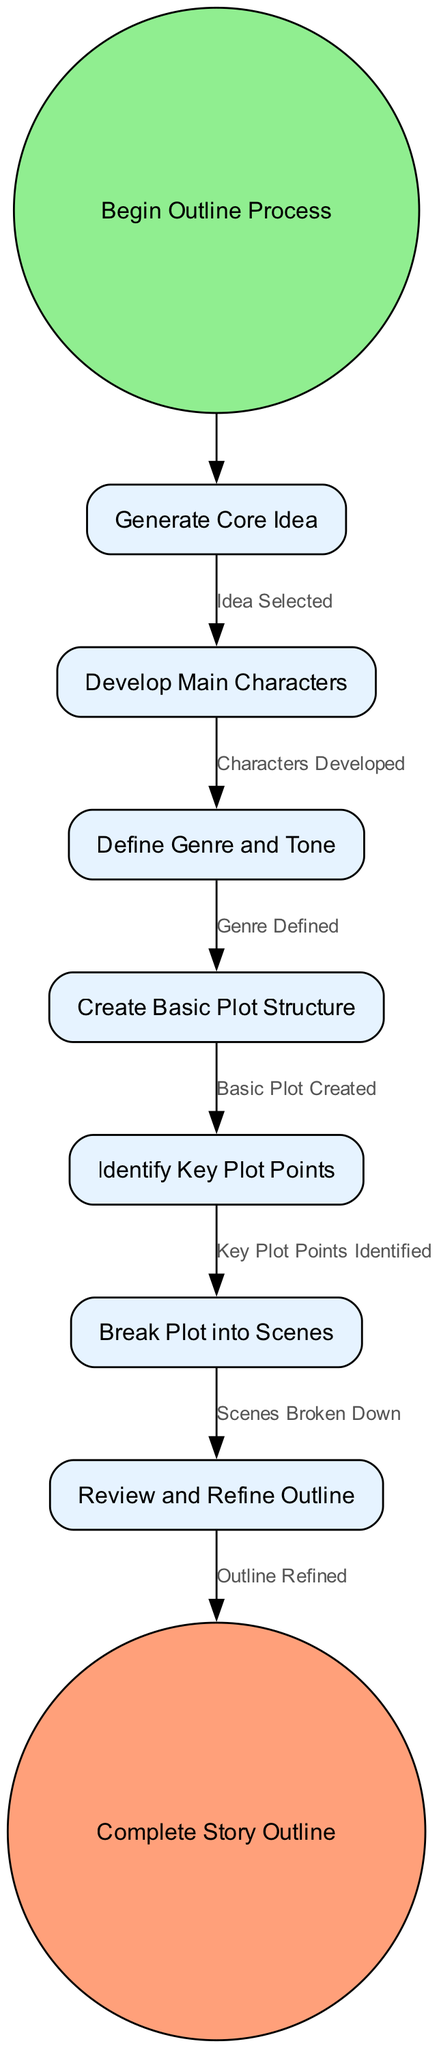What is the starting point of the outline process? The diagram indicates that the starting point is a node labeled "Begin Outline Process." This node is categorized as a start event, which signifies the beginning of the workflow for creating a story outline.
Answer: Begin Outline Process What is the last activity before completing the story outline? According to the transitions in the diagram, the last activity before reaching the end event is "Review and Refine Outline." This indicates the final step that needs to be completed before the outline is considered finished.
Answer: Review and Refine Outline How many activities are involved in the outline process? The diagram lists a total of seven activities, which are: Generate Core Idea, Develop Main Characters, Define Genre and Tone, Create Basic Plot Structure, Identify Key Plot Points, Break Plot into Scenes, and Review and Refine Outline. These are all the steps taken to create the outline.
Answer: Seven Which activity follows the identification of key plot points? Following the activity "Identify Key Plot Points," the diagram indicates that the next activity is "Break Plot into Scenes." This shows the flow of the outline process after key plot points have been determined.
Answer: Break Plot into Scenes What condition must be met to move from defining genre to creating a basic plot structure? The transition from "Define Genre and Tone" to "Create Basic Plot Structure" requires the condition "Genre Defined." This means that the genre must be clearly established before moving on to plot creation.
Answer: Genre Defined Which two activities are connected by the condition "Outline Refined"? The diagram shows that the condition "Outline Refined" connects the activity "Review and Refine Outline" to the end event "Complete Story Outline." This depicts the transition from refining the outline to finalizing it.
Answer: Review and Refine Outline and Complete Story Outline What type of event is "Complete Story Outline"? "Complete Story Outline" is categorized as an end event in the diagram. This indicates that it signifies the completion of the entire outline process, marking the endpoint of the activities defined in the diagram.
Answer: End event 